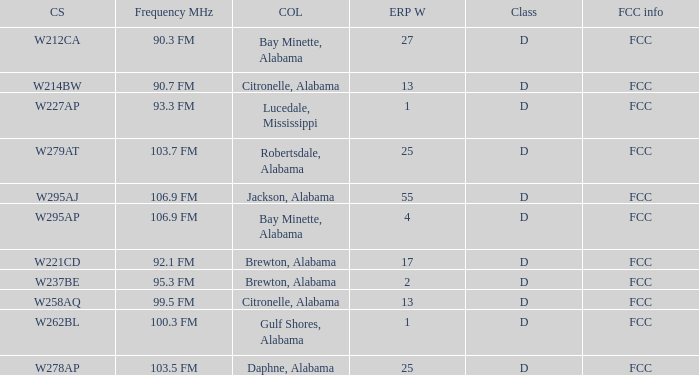Name the frequence MHz for ERP W of 55 106.9 FM. 